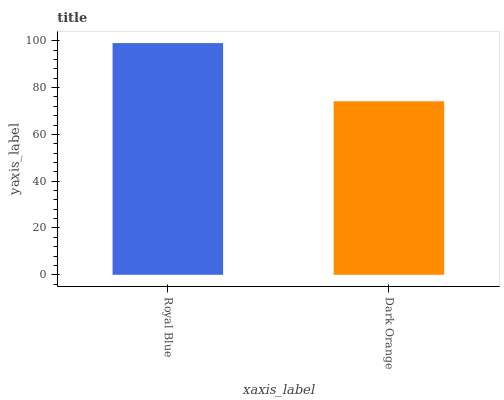Is Dark Orange the minimum?
Answer yes or no. Yes. Is Royal Blue the maximum?
Answer yes or no. Yes. Is Dark Orange the maximum?
Answer yes or no. No. Is Royal Blue greater than Dark Orange?
Answer yes or no. Yes. Is Dark Orange less than Royal Blue?
Answer yes or no. Yes. Is Dark Orange greater than Royal Blue?
Answer yes or no. No. Is Royal Blue less than Dark Orange?
Answer yes or no. No. Is Royal Blue the high median?
Answer yes or no. Yes. Is Dark Orange the low median?
Answer yes or no. Yes. Is Dark Orange the high median?
Answer yes or no. No. Is Royal Blue the low median?
Answer yes or no. No. 